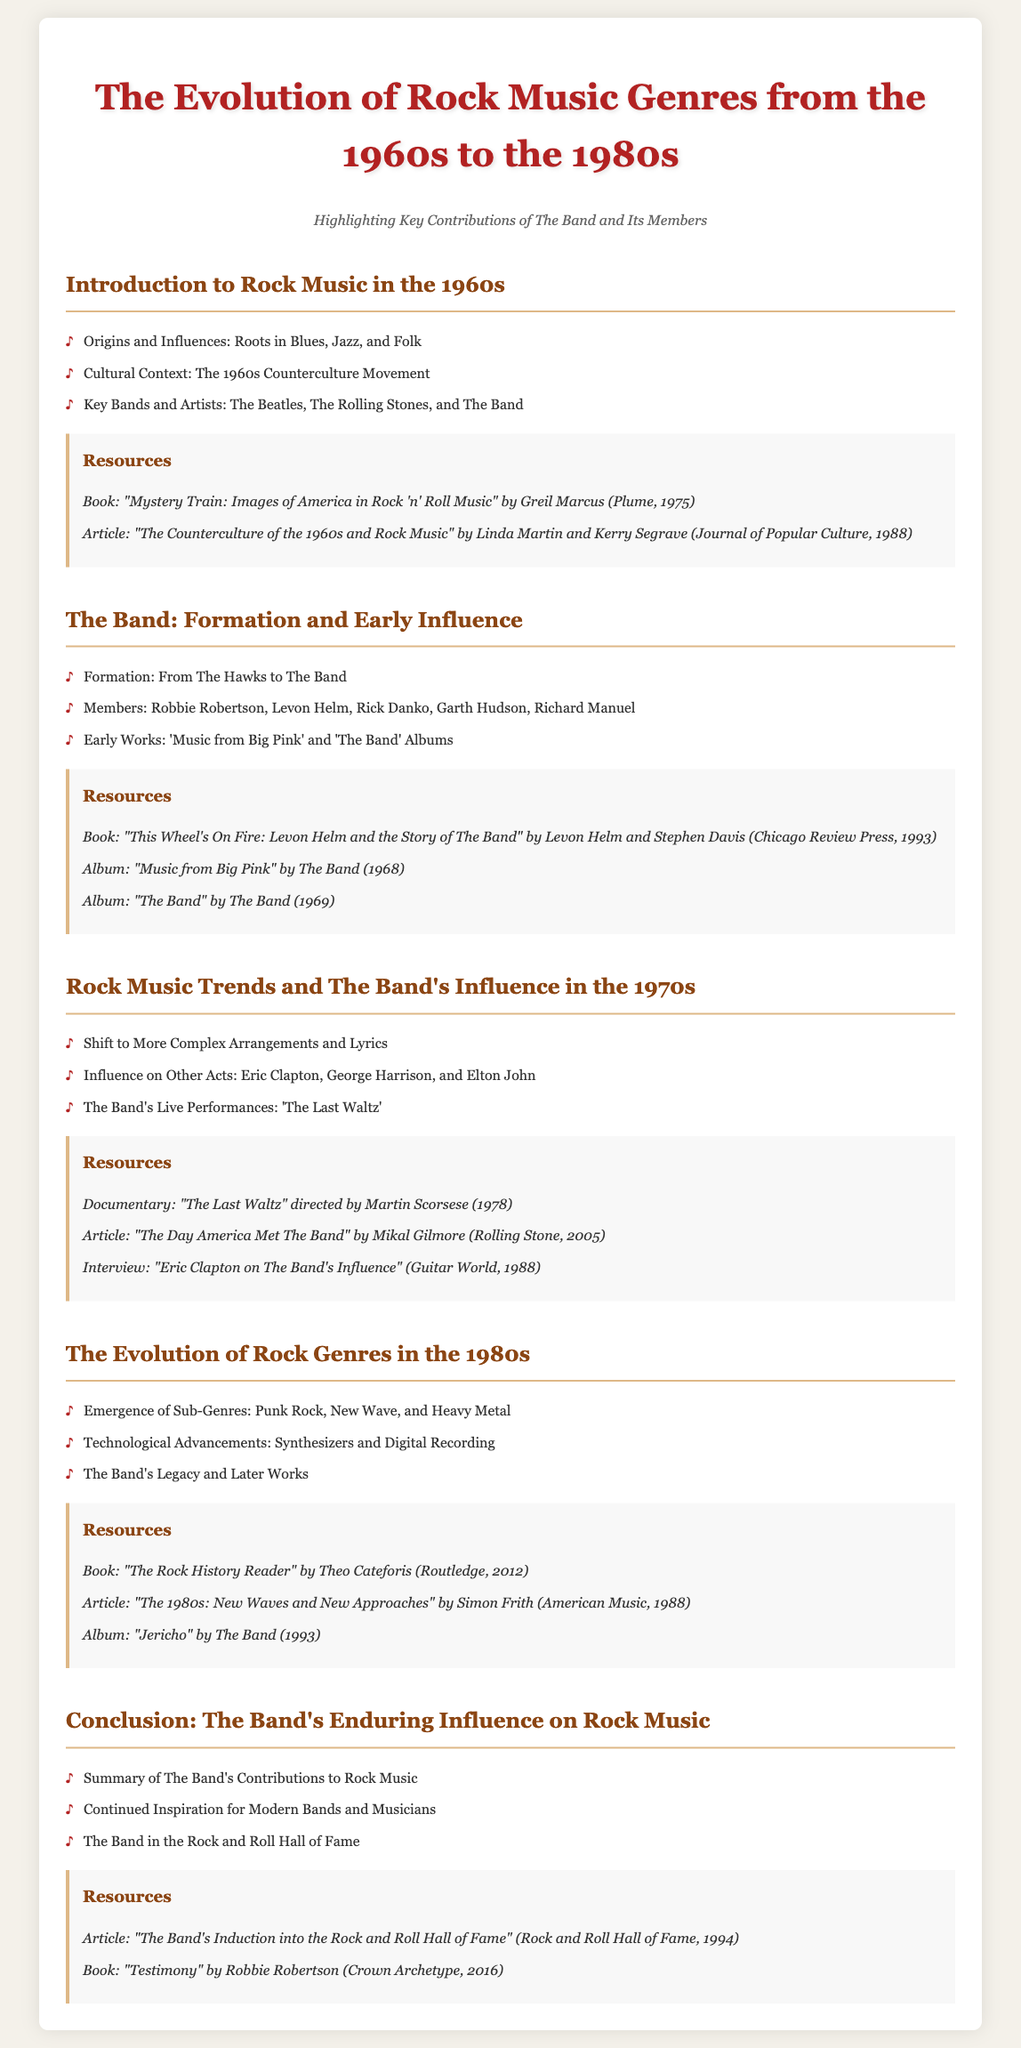What are the roots of rock music? The document states that the roots of rock music are in Blues, Jazz, and Folk.
Answer: Blues, Jazz, and Folk Who are the members of The Band? The document lists the members of The Band as Robbie Robertson, Levon Helm, Rick Danko, Garth Hudson, and Richard Manuel.
Answer: Robbie Robertson, Levon Helm, Rick Danko, Garth Hudson, Richard Manuel What year was "Music from Big Pink" released? The document mentions that "Music from Big Pink" was released in 1968.
Answer: 1968 What is the title of the documentary directed by Martin Scorsese? The document refers to the documentary directed by Martin Scorsese as "The Last Waltz."
Answer: The Last Waltz What significant change occurred in rock music trends during the 1970s? The document indicates that there was a shift to more complex arrangements and lyrics in rock music during the 1970s.
Answer: More complex arrangements and lyrics What genre of music primarily emerged during the 1980s according to the syllabus? The document notes the emergence of Punk Rock, New Wave, and Heavy Metal as sub-genres in the 1980s.
Answer: Punk Rock, New Wave, Heavy Metal What is the title of Robbie Robertson's book? The document states that the title of Robbie Robertson's book is "Testimony."
Answer: Testimony In what year was The Band inducted into the Rock and Roll Hall of Fame? The document specifies that The Band was inducted in 1994.
Answer: 1994 What was a major live performance by The Band? The document highlights 'The Last Waltz' as a major live performance by The Band.
Answer: The Last Waltz 